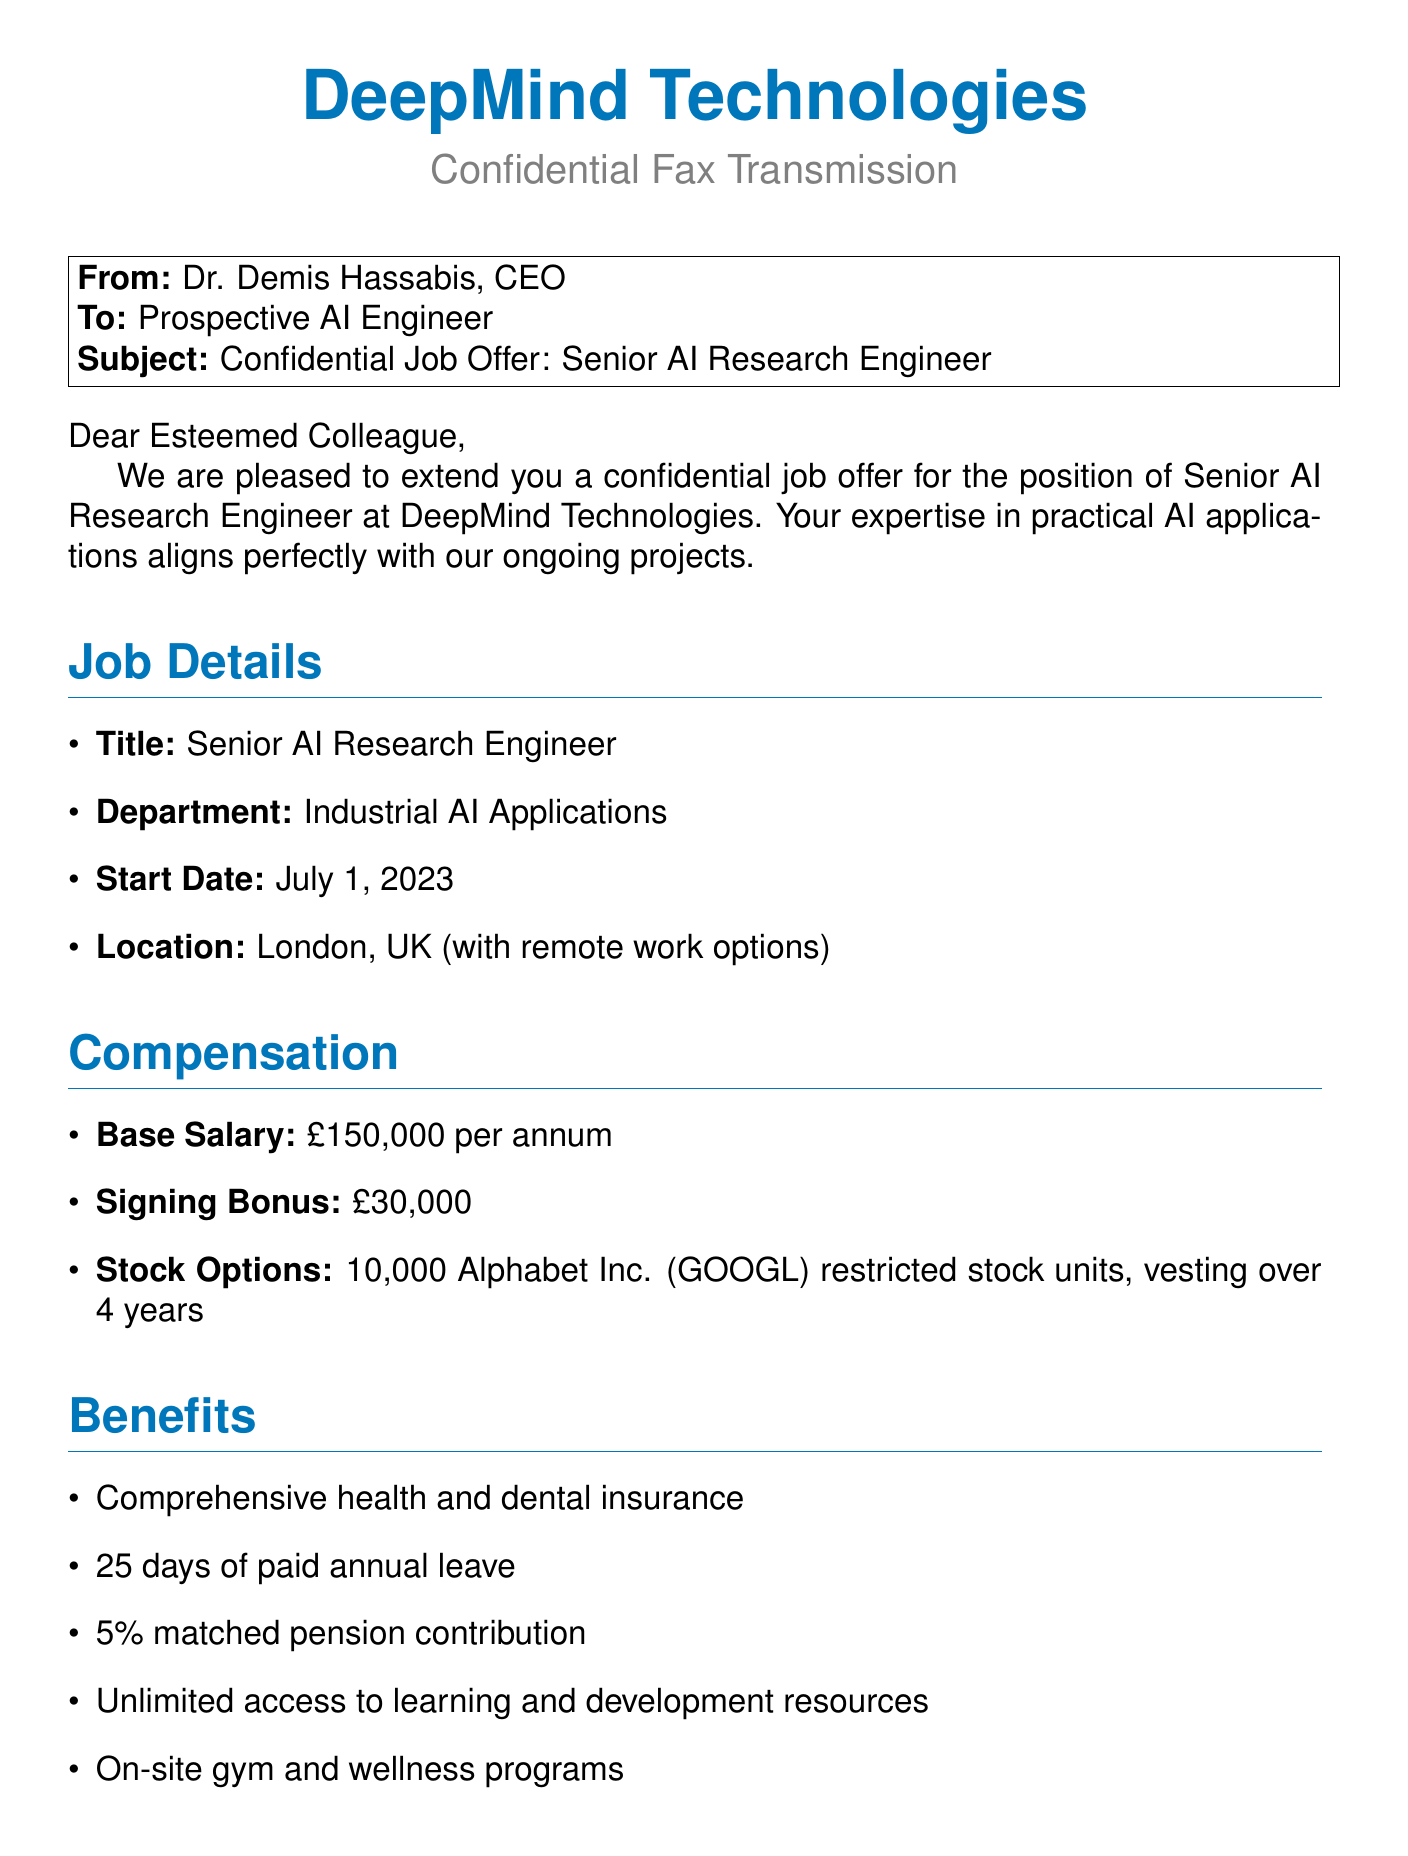What is the title of the job offer? The title of the job offer is listed in the job details section of the document.
Answer: Senior AI Research Engineer What is the base salary offered? The base salary is explicitly mentioned under the compensation section.
Answer: £150,000 per annum How many days of paid annual leave are provided? The number of days for paid annual leave is stated in the benefits section of the document.
Answer: 25 days Who is the sender of the fax? The sender's name is provided at the end of the document.
Answer: Dr. Demis Hassabis What is the signing bonus amount? The signing bonus amount is detailed in the compensation section.
Answer: £30,000 In which city is the job located? The job location is specified in the job details section of the document.
Answer: London, UK What is the first project responsibility listed? The project responsibilities start with a specific task mentioned in the document.
Answer: Lead the development of AI solutions for manufacturing optimization How many stock options are included in the offer? The number of stock options is mentioned in the compensation section.
Answer: 10,000 What is the confidentiality clause about? The confidentiality clause is included to highlight the nature of the offer.
Answer: Strictly confidential 